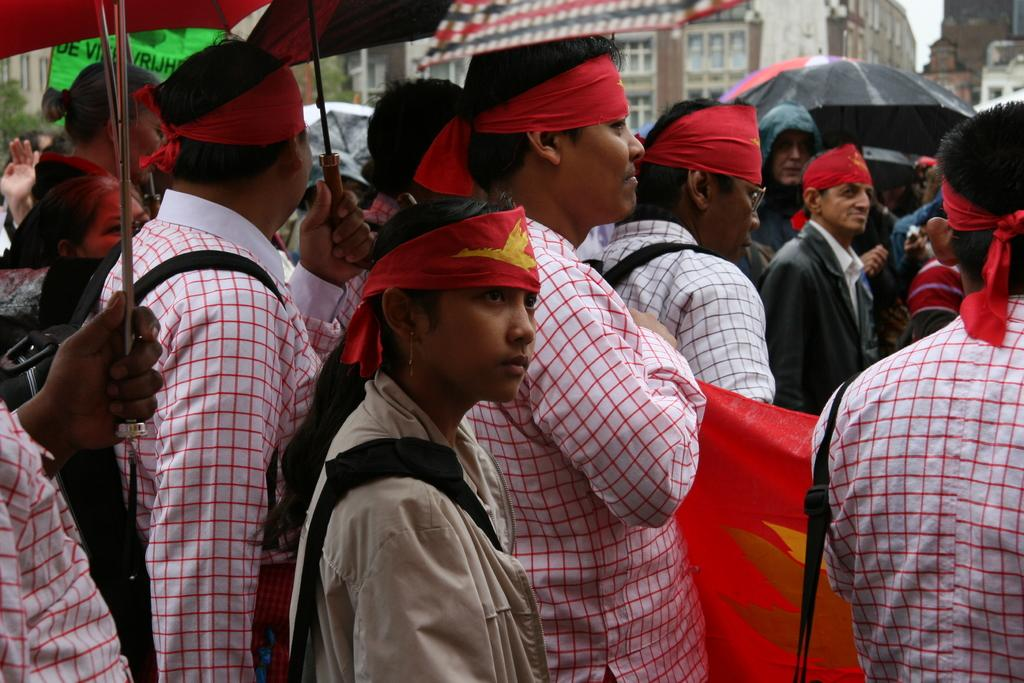What can be seen in the image? There is a group of people in the image. What are the people wearing? The people are wearing white color scarves. What are the people holding? The people are holding umbrellas. What can be seen in the background of the image? There is a building visible at the top of the image. What type of drum can be heard playing in the image? There is no drum present in the image, and therefore no sound can be heard. 